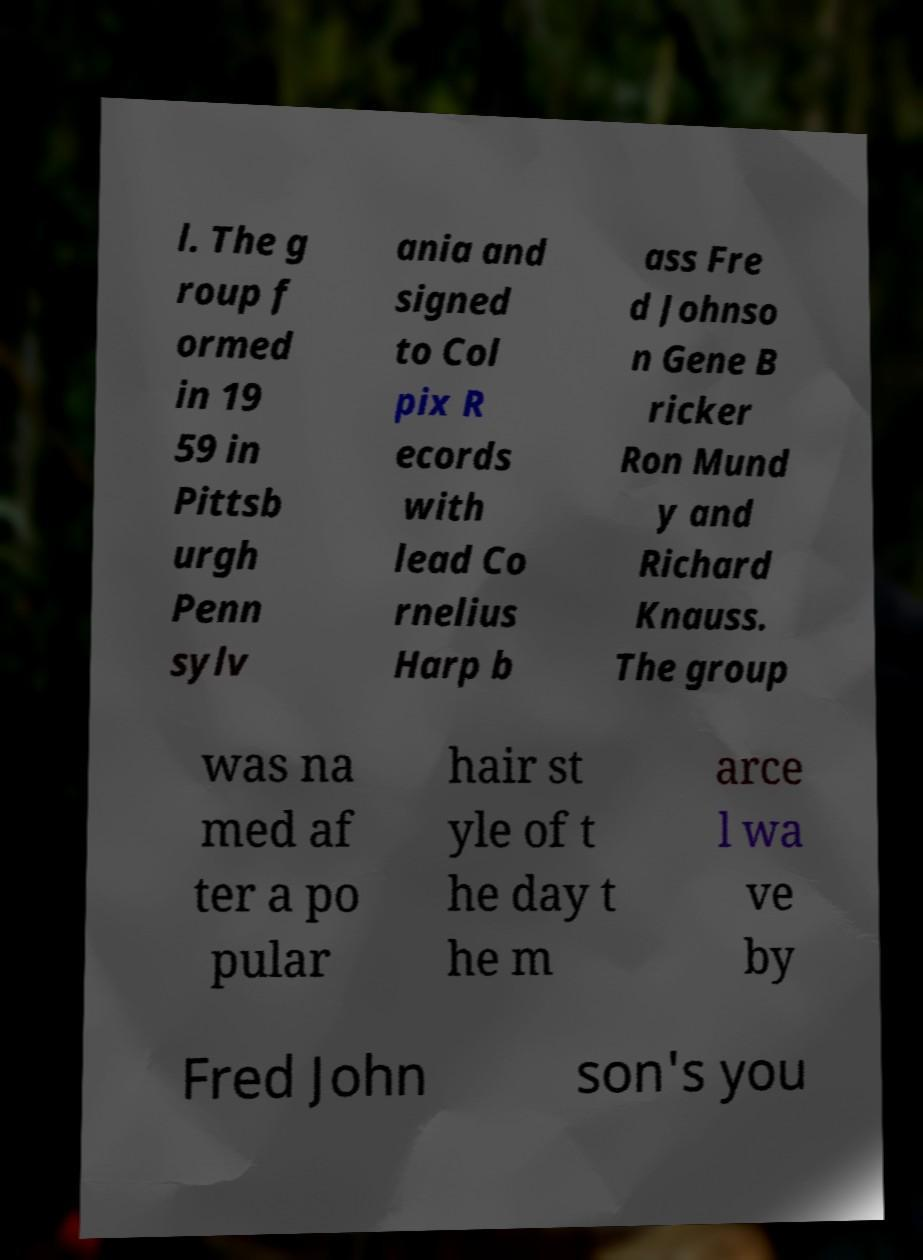There's text embedded in this image that I need extracted. Can you transcribe it verbatim? l. The g roup f ormed in 19 59 in Pittsb urgh Penn sylv ania and signed to Col pix R ecords with lead Co rnelius Harp b ass Fre d Johnso n Gene B ricker Ron Mund y and Richard Knauss. The group was na med af ter a po pular hair st yle of t he day t he m arce l wa ve by Fred John son's you 